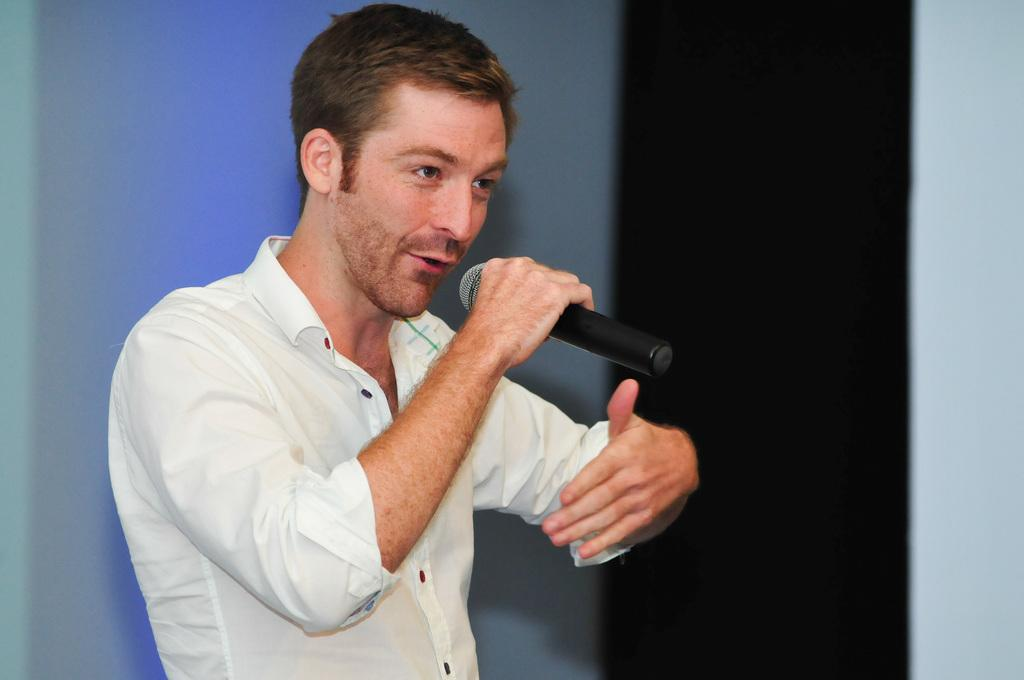What is the man in the image doing? The man is holding a guitar and talking. What is the man wearing in the image? The man is wearing a white shirt. What can be seen in the background of the image? There is a blue wall in the background of the image. Can you see any fans in the image? There are no fans visible in the image. What type of clouds can be seen in the image? There are no clouds present in the image. 